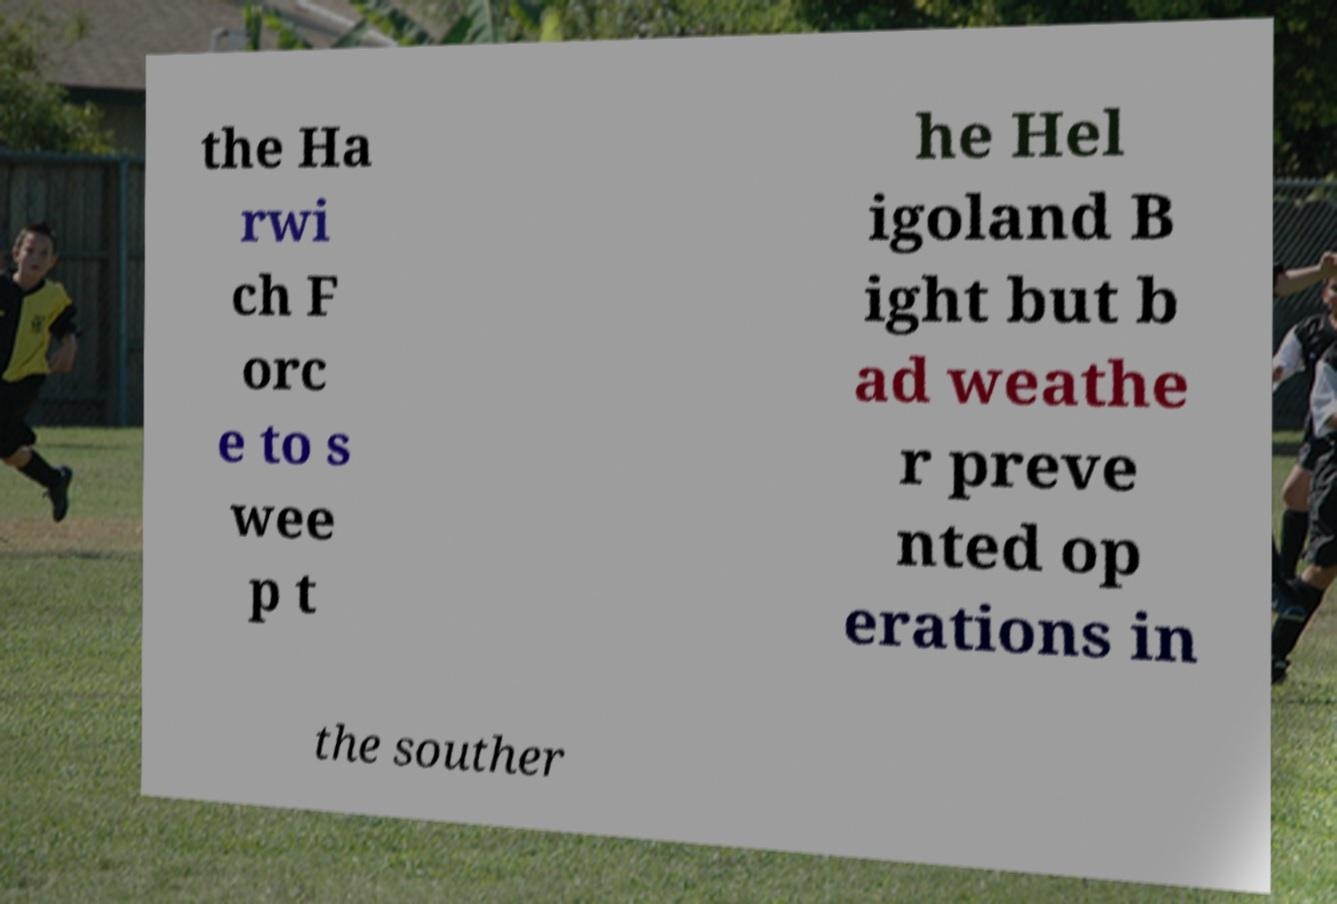For documentation purposes, I need the text within this image transcribed. Could you provide that? the Ha rwi ch F orc e to s wee p t he Hel igoland B ight but b ad weathe r preve nted op erations in the souther 